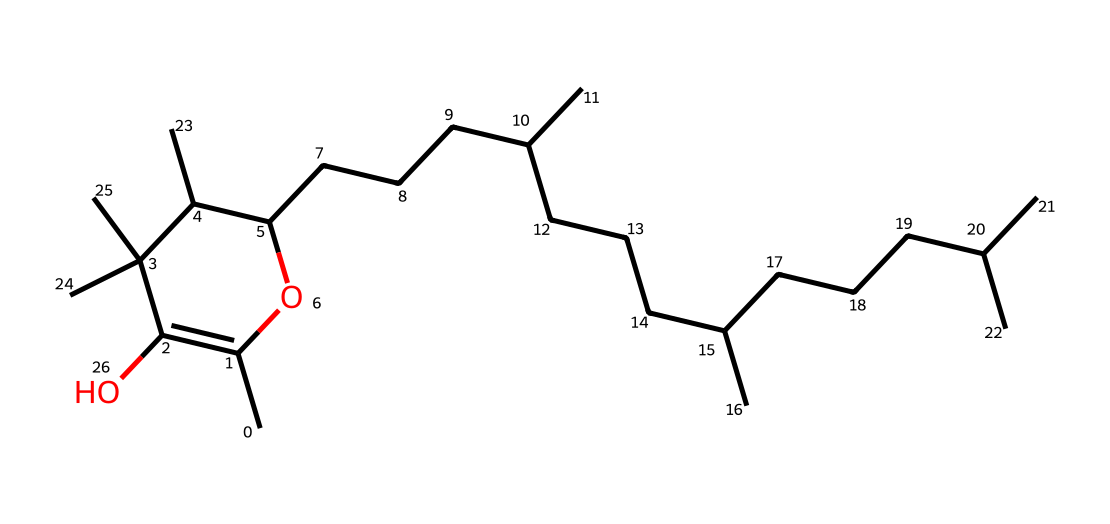What is the chemical name of the structure represented? The structure corresponds to tocopherol, a form of vitamin E. This is recognized by its common name as a vitamin with antioxidant properties.
Answer: tocopherol How many carbon atoms are present in this chemical structure? After analyzing the structure, by counting each carbon atom (C) from the SMILES representation provided, there are 55 carbon atoms.
Answer: 55 What functional groups are present in this chemical? The chemical contains hydroxyl (-OH) groups, which are indicated by the presence of oxygen bonded to hydrogen in the structure, contributing to its biological activity.
Answer: hydroxyl groups What type of vitamin is tocopherol classified as? Tocopherol is classified as a fat-soluble vitamin, which can be inferred from its large hydrocarbon chain and multiple carbon atoms associated with fatty substances.
Answer: fat-soluble What is the primary biological function of tocopherol? Tocopherol primarily acts as an antioxidant, preventing oxidative damage to cells, as understood from its role in protecting unsaturated fats in the body.
Answer: antioxidant How many hydroxyl groups are in tocopherol? There are two hydroxyl groups visible in the structure, indicating points of potential reactivity and interaction in biological systems.
Answer: 2 